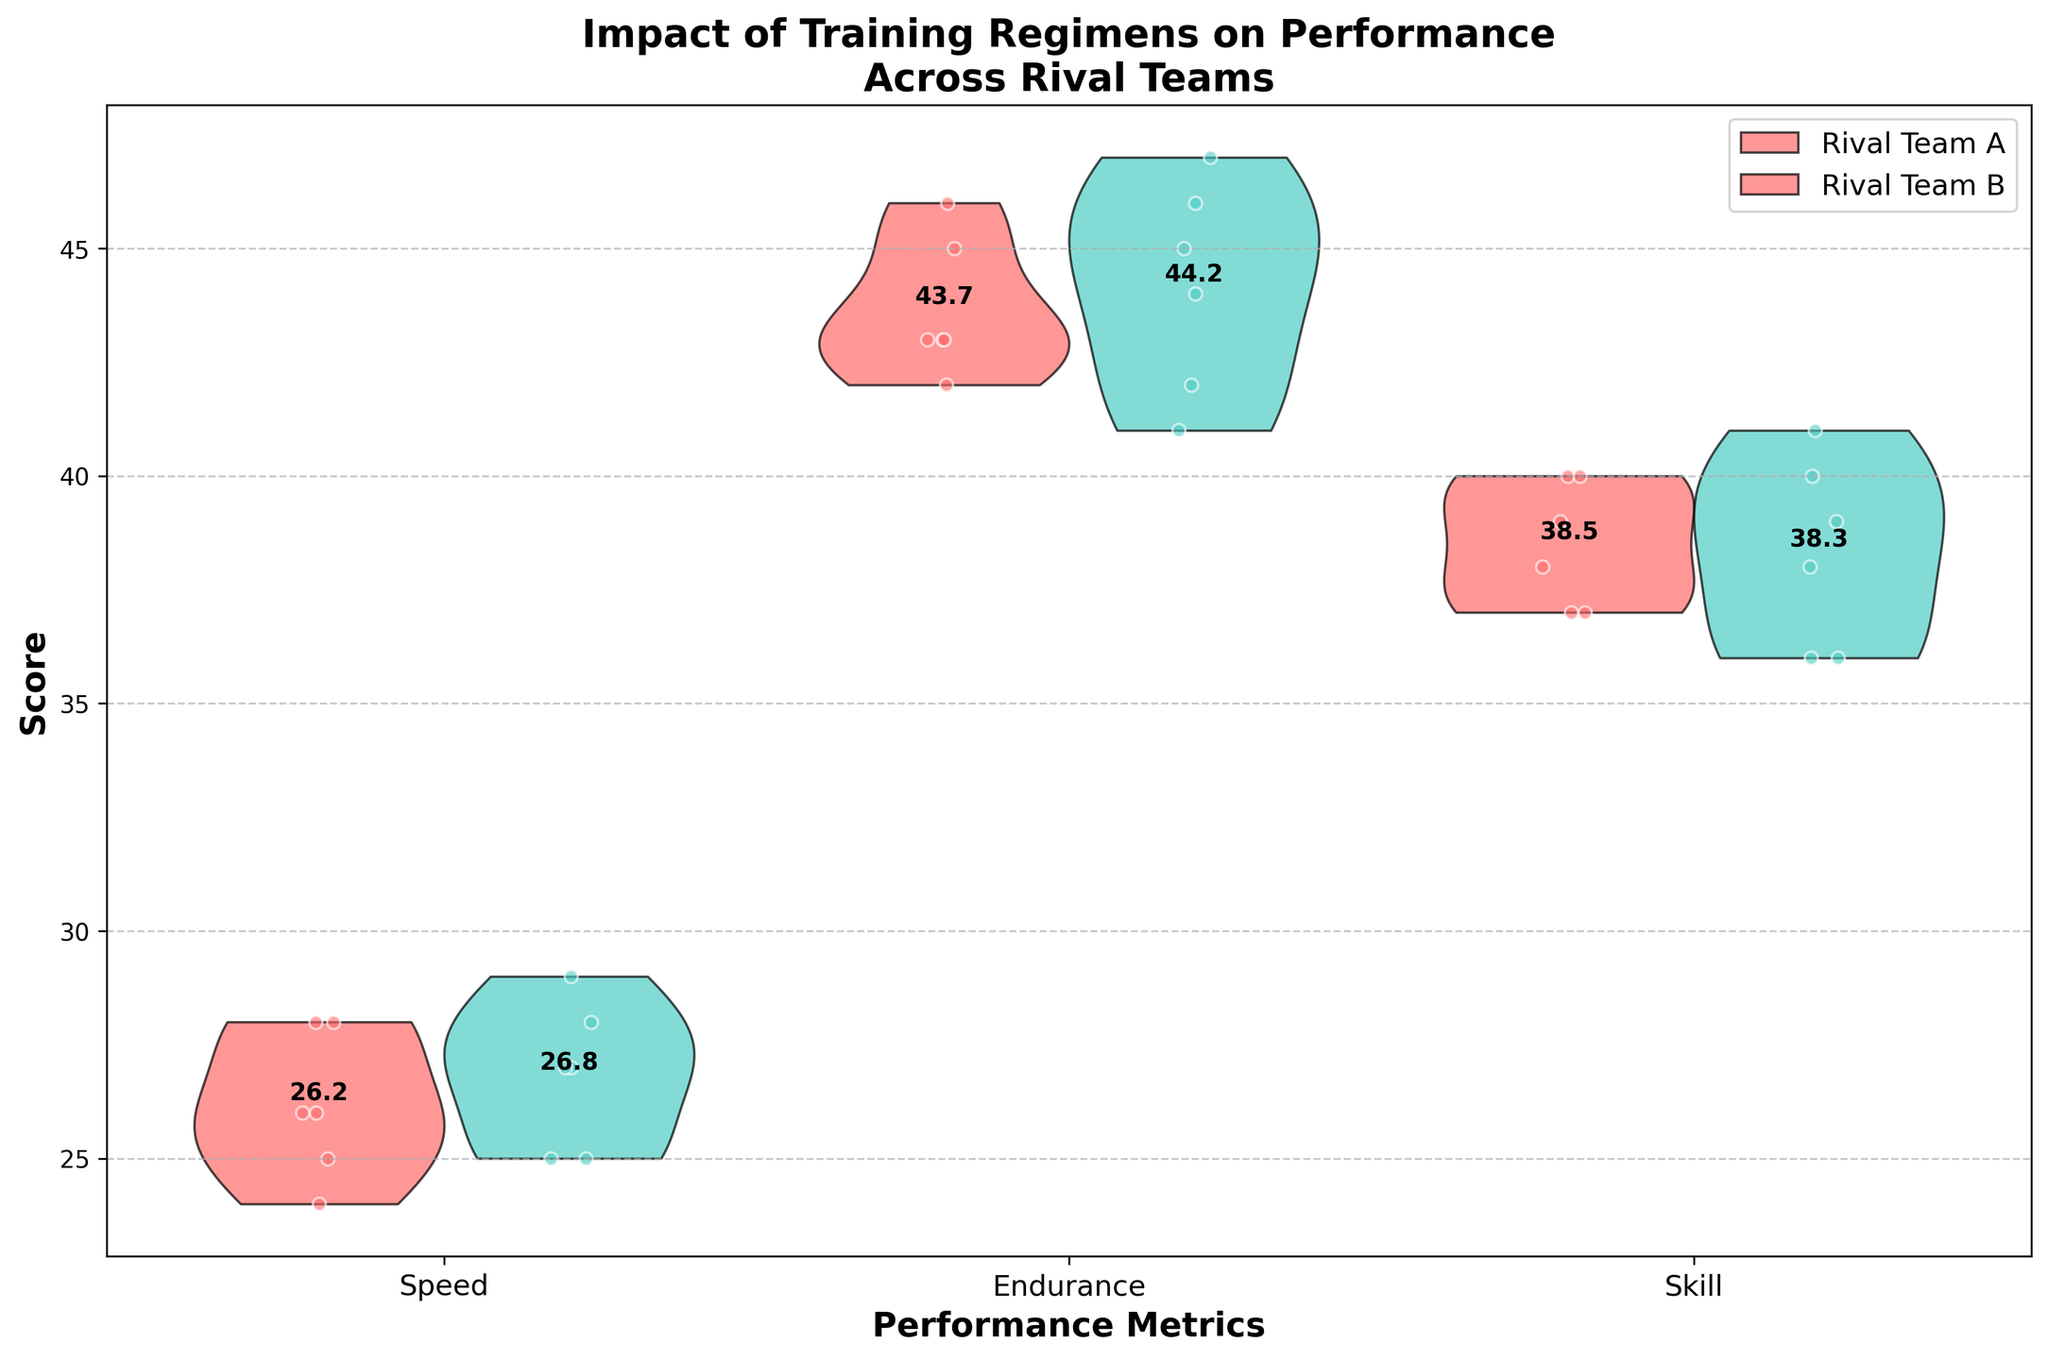Which team has the highest average Skill score? To find the highest average Skill score, observe the annotation text indicating the averages on the violin plot for Skill. Compare the averages for Rival Team A and Rival Team B.
Answer: Rival Team B What is the title of the violin plot? The title is displayed prominently at the top of the figure.
Answer: Impact of Training Regimens on Performance Across Rival Teams How does the average Endurance score for Rival Team A compare to Rival Team B? Check the annotated average values on the violin plot for Endurance. Compare the averages for both teams by looking at their respective positions on the y-axis.
Answer: Rival Team B has a higher average Endurance score than Rival Team A Which metric has the lowest average score for Rival Team A? Look at the annotated average scores for all three metrics (Speed, Endurance, Skill) for Rival Team A in the figure. Identify the lowest value among these.
Answer: Speed What is the average Speed score for Rival Team B? Locate the annotated average value for Speed corresponding to Rival Team B on the violin plot.
Answer: 27.6 Which training regimen appears most frequently for Rival Team A in this dataset? Look closely at the jittered points and their associated training regimens for Rival Team A. Identify the regimen that appears most often.
Answer: Strength Training Do both Rival Team A and Rival Team B have similar distributions for any of the performance metrics? Compare the shapes and spreads of the violins for each metric for both teams by visually assessing their overlap and symmetry.
Answer: Yes, especially for Skill Is there a noticeable difference in the spread of Endurance scores between the two teams? Examine the width and distribution of the Endurance violins for both Rival Team A and Rival Team B. Note any differences in spread.
Answer: Yes, Rival Team B has a wider spread What color represents Rival Team A in the violin plot? Identify the fill color of the violins corresponding to Rival Team A.
Answer: Red For which metric does Rival Team B have the highest average score? Compare the annotated average values for Speed, Endurance, and Skill for Rival Team B and choose the highest one.
Answer: Endurance 